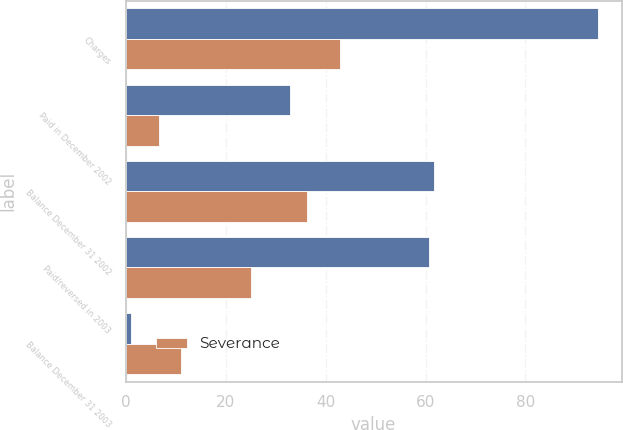<chart> <loc_0><loc_0><loc_500><loc_500><stacked_bar_chart><ecel><fcel>Charges<fcel>Paid in December 2002<fcel>Balance December 31 2002<fcel>Paid/reversed in 2003<fcel>Balance December 31 2003<nl><fcel>nan<fcel>94.5<fcel>32.9<fcel>61.6<fcel>60.6<fcel>1<nl><fcel>Severance<fcel>42.8<fcel>6.6<fcel>36.2<fcel>25.1<fcel>11.1<nl></chart> 